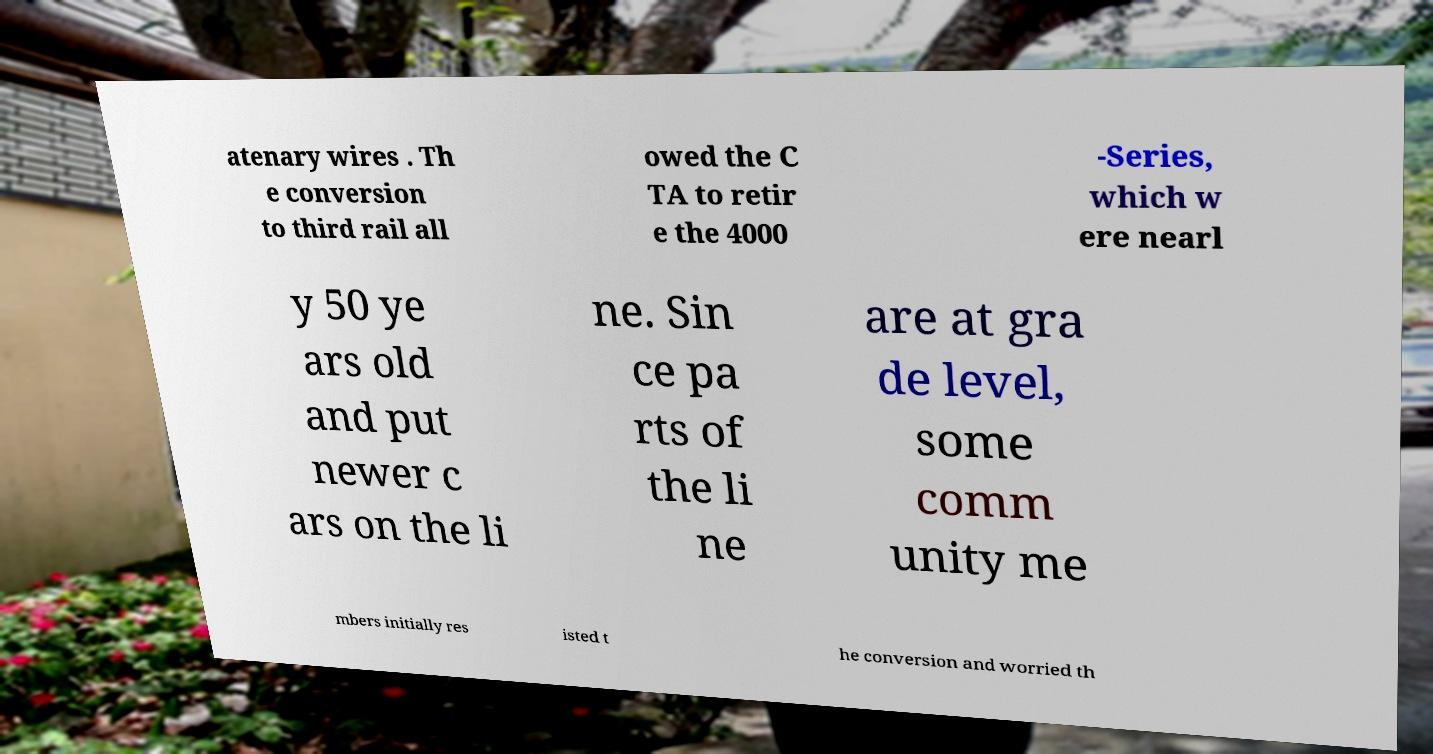Can you read and provide the text displayed in the image?This photo seems to have some interesting text. Can you extract and type it out for me? atenary wires . Th e conversion to third rail all owed the C TA to retir e the 4000 -Series, which w ere nearl y 50 ye ars old and put newer c ars on the li ne. Sin ce pa rts of the li ne are at gra de level, some comm unity me mbers initially res isted t he conversion and worried th 